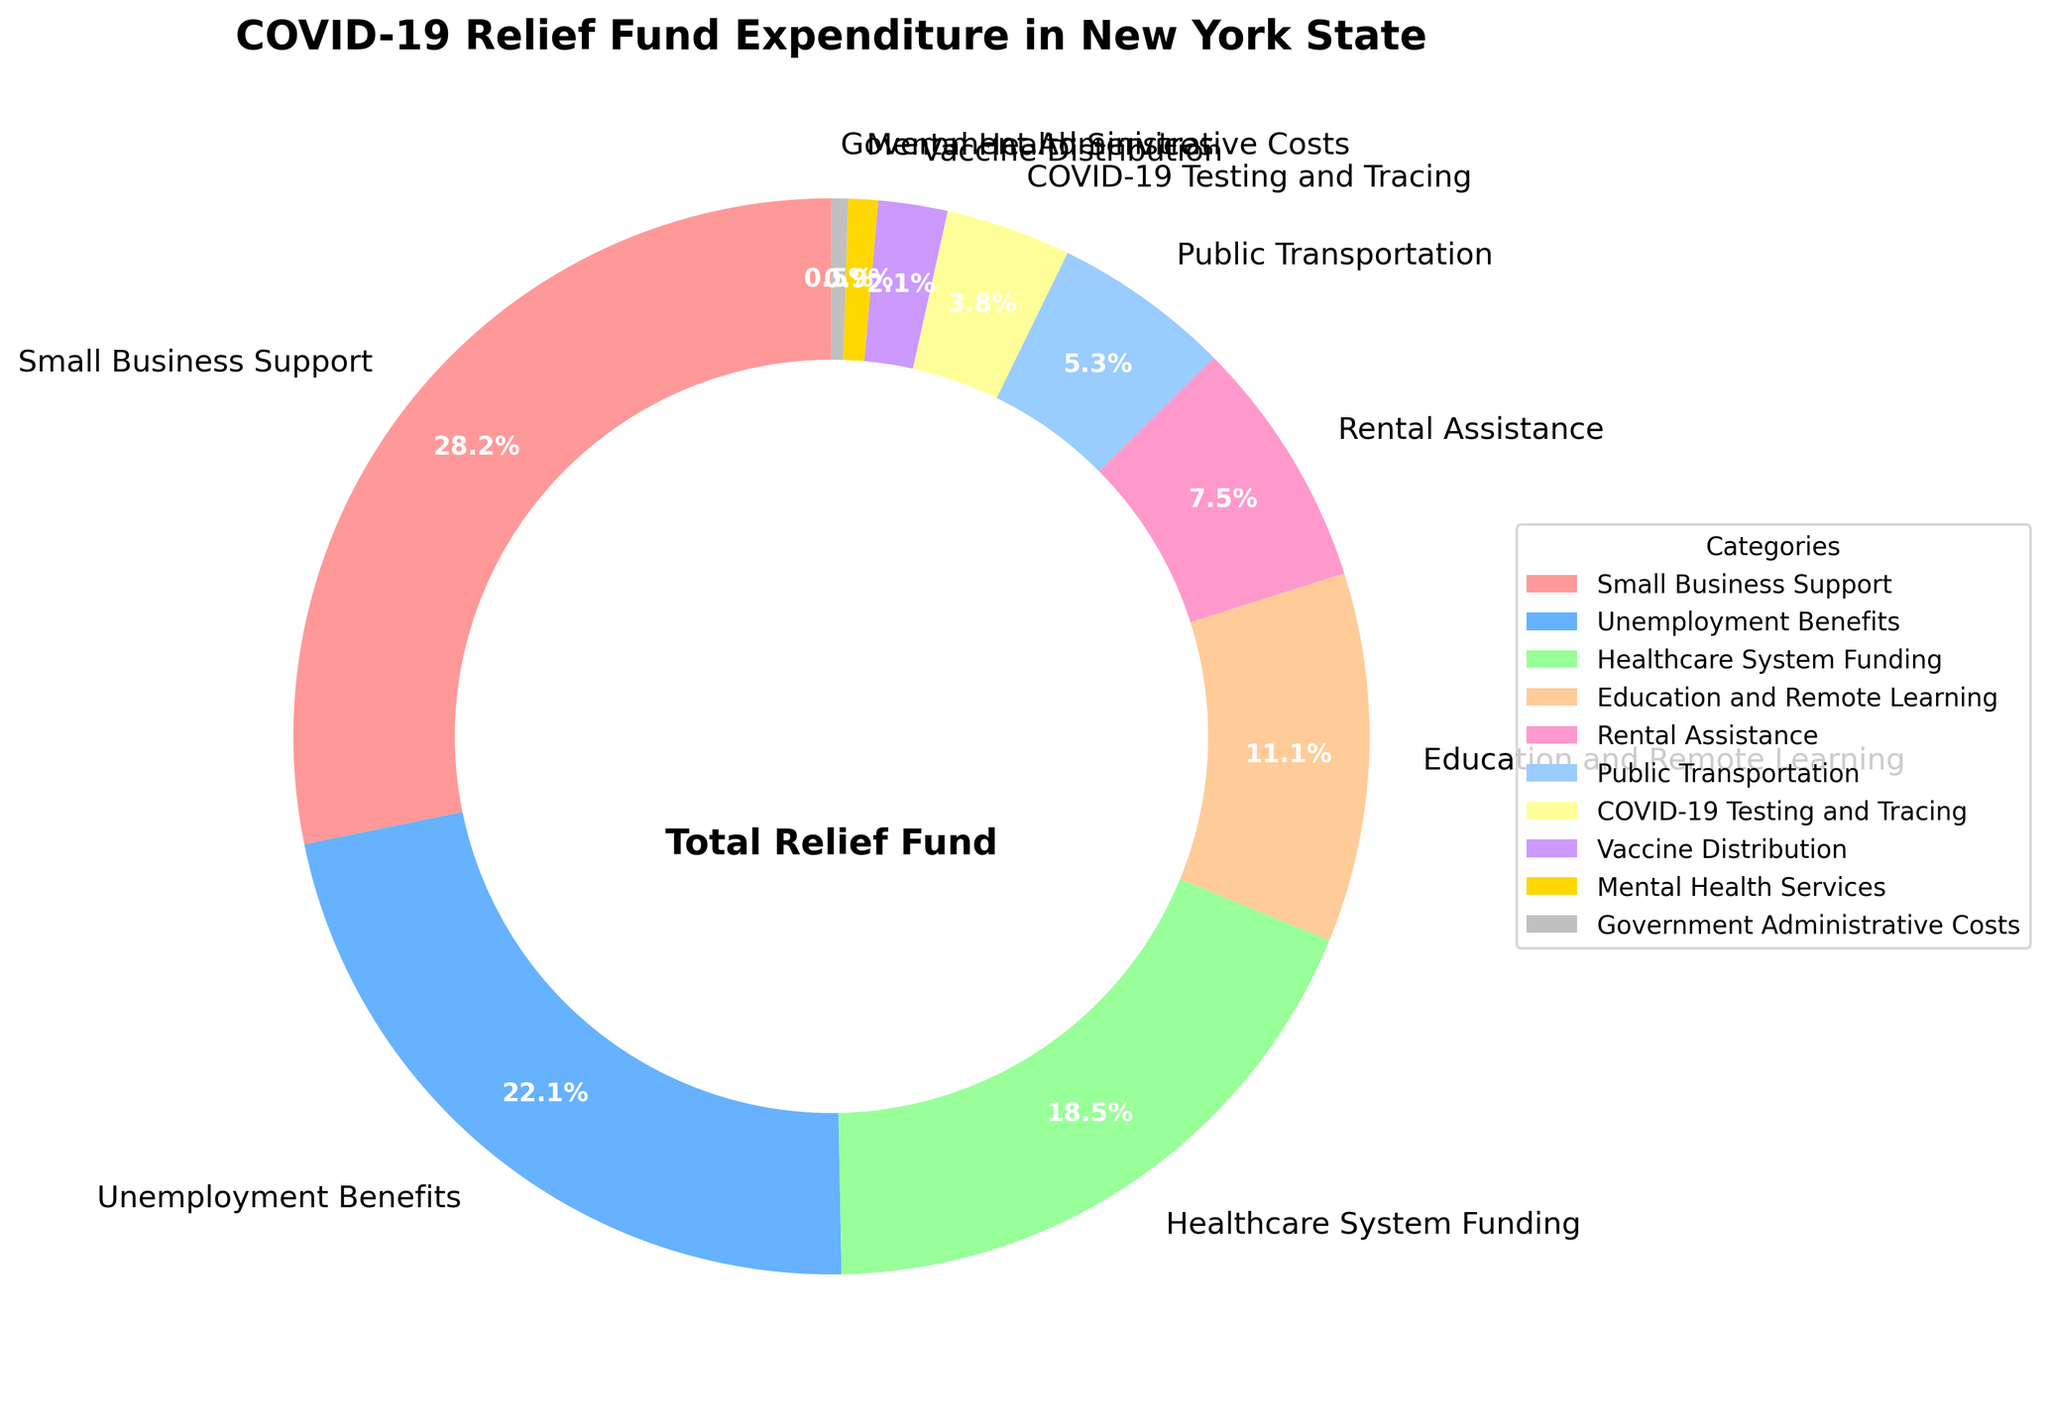Which category received the highest percentage of the COVID-19 relief fund? The largest segment in the pie chart corresponds to "Small Business Support" which occupies 28.5% of the relief fund.
Answer: Small Business Support Which category has a smaller percentage allocation: Rental Assistance or Public Transportation? By comparing the slices, Rental Assistance is represented as 7.6% while Public Transportation is 5.4%. Since 5.4% is less than 7.6%, Public Transportation has a smaller percentage allocation.
Answer: Public Transportation What is the cumulative percentage of relief funds spent on Small Business Support and Unemployment Benefits? Small Business Support has 28.5% and Unemployment Benefits have 22.3%. Adding these together results in a total: 28.5% + 22.3% = 50.8%.
Answer: 50.8% Is the percentage allocated to Healthcare System Funding greater than Education and Remote Learning? Healthcare System Funding is represented as 18.7% whereas Education and Remote Learning is 11.2%. Since 18.7% is greater than 11.2%, the allocation to Healthcare System Funding is indeed greater.
Answer: Yes What is the difference in percentage between categories receiving the highest and the lowest funds? The highest allocation is 28.5% for Small Business Support, and the lowest allocation is 0.5% for Government Administrative Costs. The difference is 28.5% - 0.5% = 28.0%.
Answer: 28.0% Which categories combined make up less than 10% of the relief fund? The segments corresponding to 3.8% (COVID-19 Testing and Tracing), 2.1% (Vaccine Distribution), 0.9% (Mental Health Services), and 0.5% (Government Administrative Costs) all sum up to less than 10%. Calculating together: 3.8% + 2.1% + 0.9% + 0.5% = 7.3%.
Answer: COVID-19 Testing and Tracing, Vaccine Distribution, Mental Health Services, Government Administrative Costs What is the average percentage allocation across all categories? Sum all percentage allocations (28.5 + 22.3 + 18.7 + 11.2 + 7.6+ 5.4 + 3.8 + 2.1 + 0.9 + 0.5) = 100%. Considering there are 10 categories, the average is 100% / 10 = 10.0%.
Answer: 10.0% List the categories with greater than 10% allocation. By examining the chart, categories with allocations greater than 10% are Small Business Support (28.5%), Unemployment Benefits (22.3%), Healthcare System Funding (18.7%), and Education and Remote Learning (11.2%).
Answer: Small Business Support, Unemployment Benefits, Healthcare System Funding, Education and Remote Learning How does the allocation for Public Transportation compare to that for Vaccine Distribution? Public Transportation has 5.4% of the total funds, while Vaccine Distribution is given 2.1%. Comparing the two, 5.4% is greater than 2.1%.
Answer: Public Transportation > Vaccine Distribution If the categories of Small Business Support, Unemployment Benefits, and Healthcare System Funding are combined, what fraction of the total relief fund do they represent? These categories sum up to 28.5% (Small Business Support) + 22.3% (Unemployment Benefits) + 18.7% (Healthcare System Funding) = 69.5%, which represents the combined fraction of the total relief fund.
Answer: 69.5% 